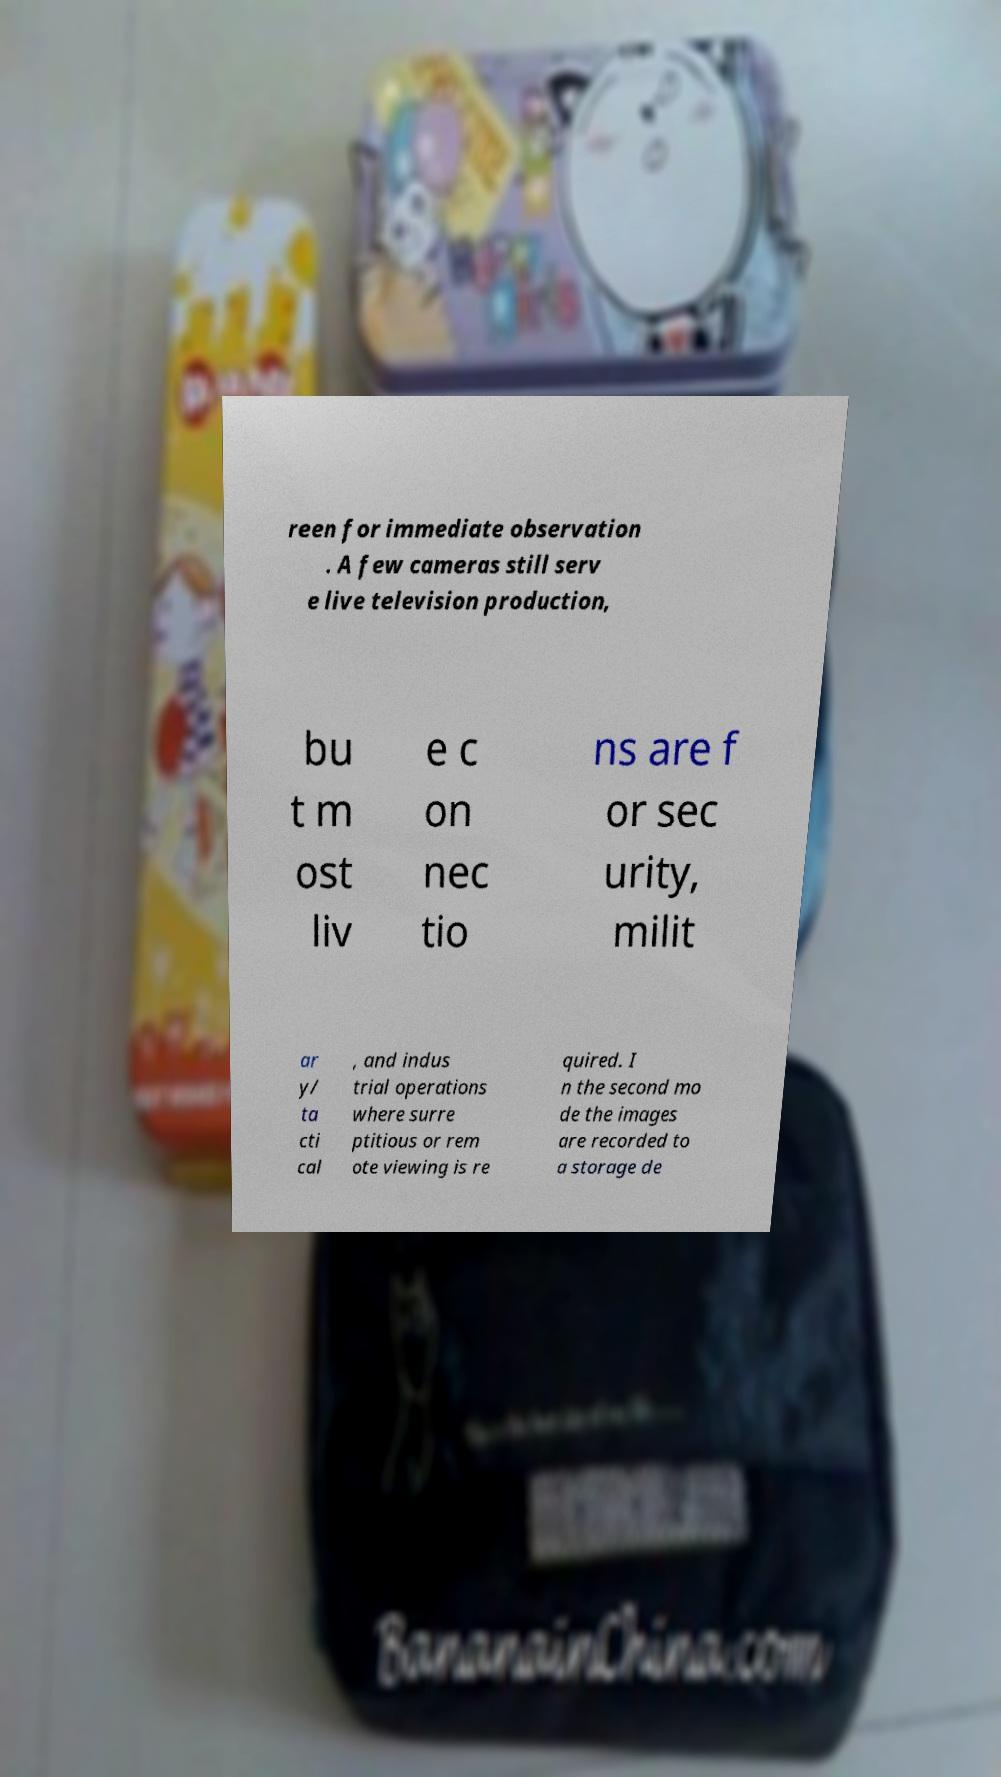Could you extract and type out the text from this image? reen for immediate observation . A few cameras still serv e live television production, bu t m ost liv e c on nec tio ns are f or sec urity, milit ar y/ ta cti cal , and indus trial operations where surre ptitious or rem ote viewing is re quired. I n the second mo de the images are recorded to a storage de 